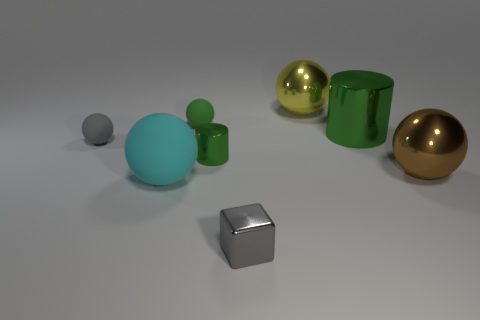What textures can be observed on the different objects? The objects in the image display surfaces that seem smooth and reflective, indicating they may be made of materials like metal or plastic. The lighting suggests a shiny, possibly polished texture on most of them. 